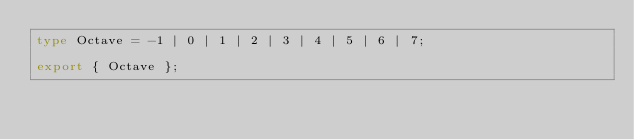Convert code to text. <code><loc_0><loc_0><loc_500><loc_500><_TypeScript_>type Octave = -1 | 0 | 1 | 2 | 3 | 4 | 5 | 6 | 7;

export { Octave };
</code> 